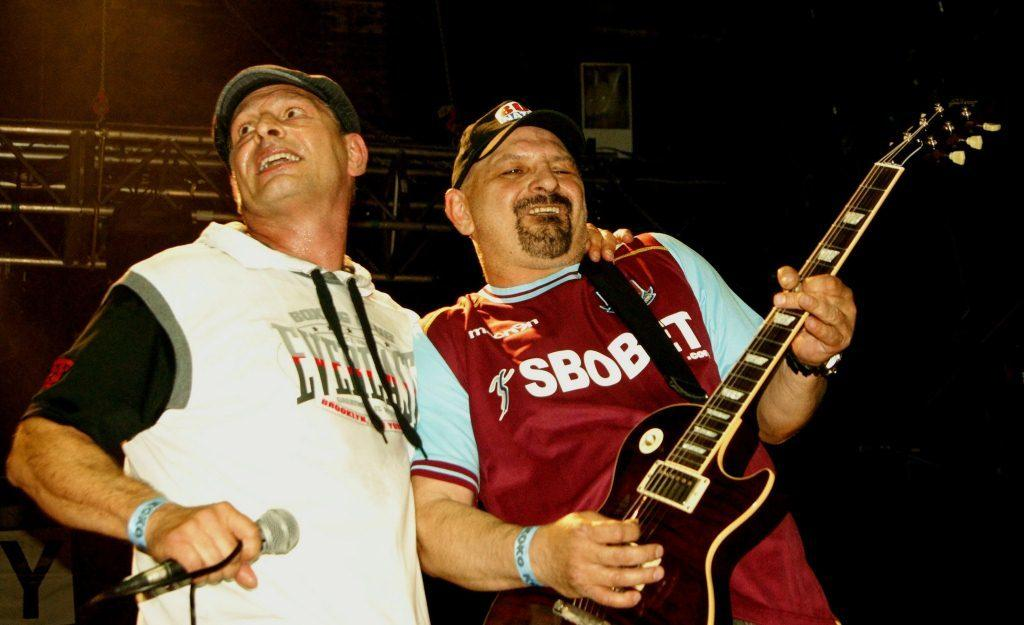How many people are in the image? There are two persons in the image. What are the people doing in the image? One person is playing a guitar, and the other person is holding a microphone. Are both persons wearing caps? Yes, both persons are wearing caps. What can be seen in the background of the image? There is a wall, rods, and a poster in the background of the image. What is the size of the alley in the image? There is no alley present in the image. What type of humor can be seen in the poster in the background? There is no humor mentioned or depicted in the poster in the background. 